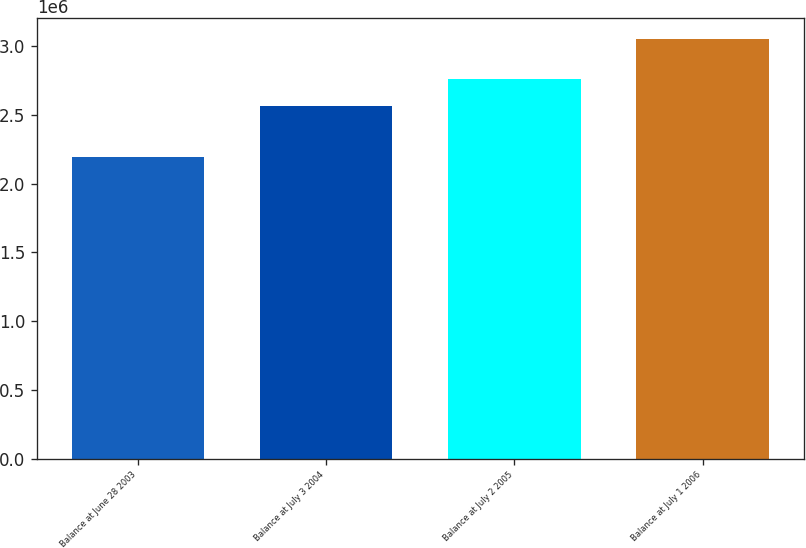Convert chart to OTSL. <chart><loc_0><loc_0><loc_500><loc_500><bar_chart><fcel>Balance at June 28 2003<fcel>Balance at July 3 2004<fcel>Balance at July 2 2005<fcel>Balance at July 1 2006<nl><fcel>2.19753e+06<fcel>2.56451e+06<fcel>2.75884e+06<fcel>3.05228e+06<nl></chart> 